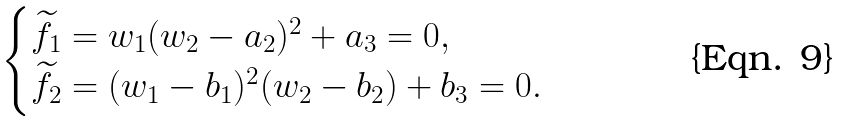Convert formula to latex. <formula><loc_0><loc_0><loc_500><loc_500>\begin{cases} \widetilde { f } _ { 1 } = w _ { 1 } ( w _ { 2 } - a _ { 2 } ) ^ { 2 } + a _ { 3 } = 0 , \\ \widetilde { f } _ { 2 } = ( w _ { 1 } - b _ { 1 } ) ^ { 2 } ( w _ { 2 } - b _ { 2 } ) + b _ { 3 } = 0 . \end{cases}</formula> 